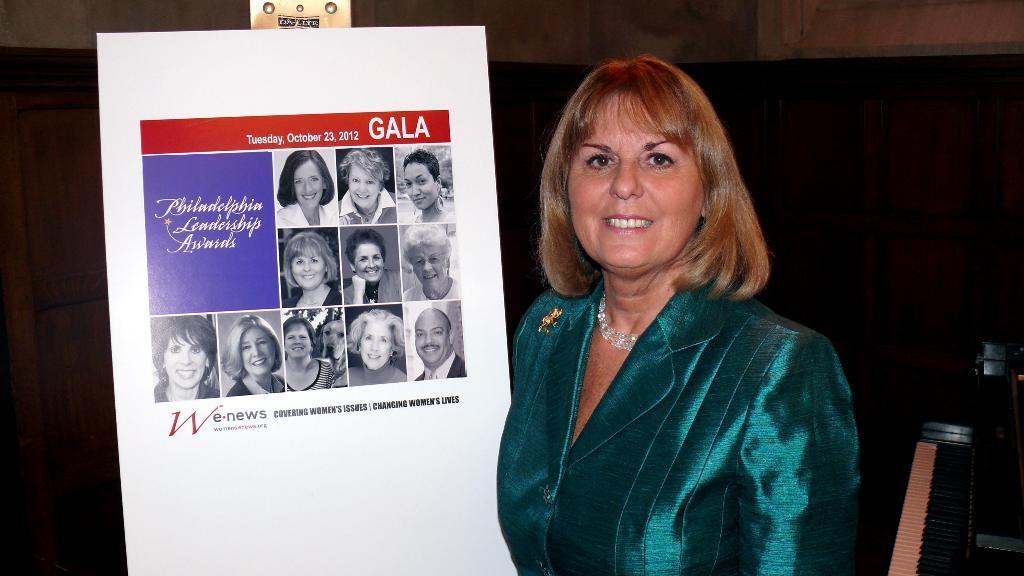Can you describe this image briefly? In front of the image there is a person standing and she is having a smile on her face. Beside her there is a board with some pictures and text on it. Behind her there are wooden cupboards. On the right side of the image there is a piano. In the background of the image there is a wall. 